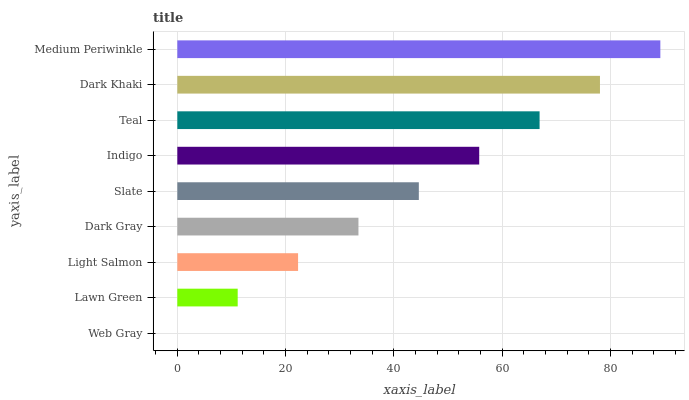Is Web Gray the minimum?
Answer yes or no. Yes. Is Medium Periwinkle the maximum?
Answer yes or no. Yes. Is Lawn Green the minimum?
Answer yes or no. No. Is Lawn Green the maximum?
Answer yes or no. No. Is Lawn Green greater than Web Gray?
Answer yes or no. Yes. Is Web Gray less than Lawn Green?
Answer yes or no. Yes. Is Web Gray greater than Lawn Green?
Answer yes or no. No. Is Lawn Green less than Web Gray?
Answer yes or no. No. Is Slate the high median?
Answer yes or no. Yes. Is Slate the low median?
Answer yes or no. Yes. Is Dark Gray the high median?
Answer yes or no. No. Is Lawn Green the low median?
Answer yes or no. No. 